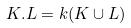Convert formula to latex. <formula><loc_0><loc_0><loc_500><loc_500>K . L = k ( K \cup L )</formula> 